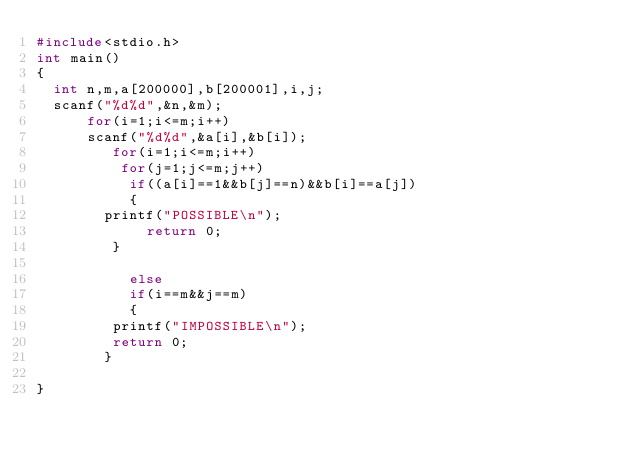<code> <loc_0><loc_0><loc_500><loc_500><_C_>#include<stdio.h>
int main()
{
	int n,m,a[200000],b[200001],i,j;
	scanf("%d%d",&n,&m);
	    for(i=1;i<=m;i++)
	    scanf("%d%d",&a[i],&b[i]);
	     	 for(i=1;i<=m;i++)
	     	  for(j=1;j<=m;j++)
	     	   if((a[i]==1&&b[j]==n)&&b[i]==a[j])
	     	   {
				printf("POSSIBLE\n");
	     	     return 0;
				 } 
	     	   
	     	   else
	     	   if(i==m&&j==m)
	     	   {
				 printf("IMPOSSIBLE\n");
				 return 0;
				}
	     	  
}</code> 